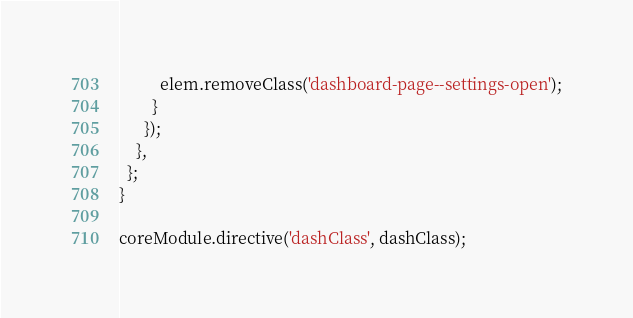<code> <loc_0><loc_0><loc_500><loc_500><_TypeScript_>          elem.removeClass('dashboard-page--settings-open');
        }
      });
    },
  };
}

coreModule.directive('dashClass', dashClass);
</code> 